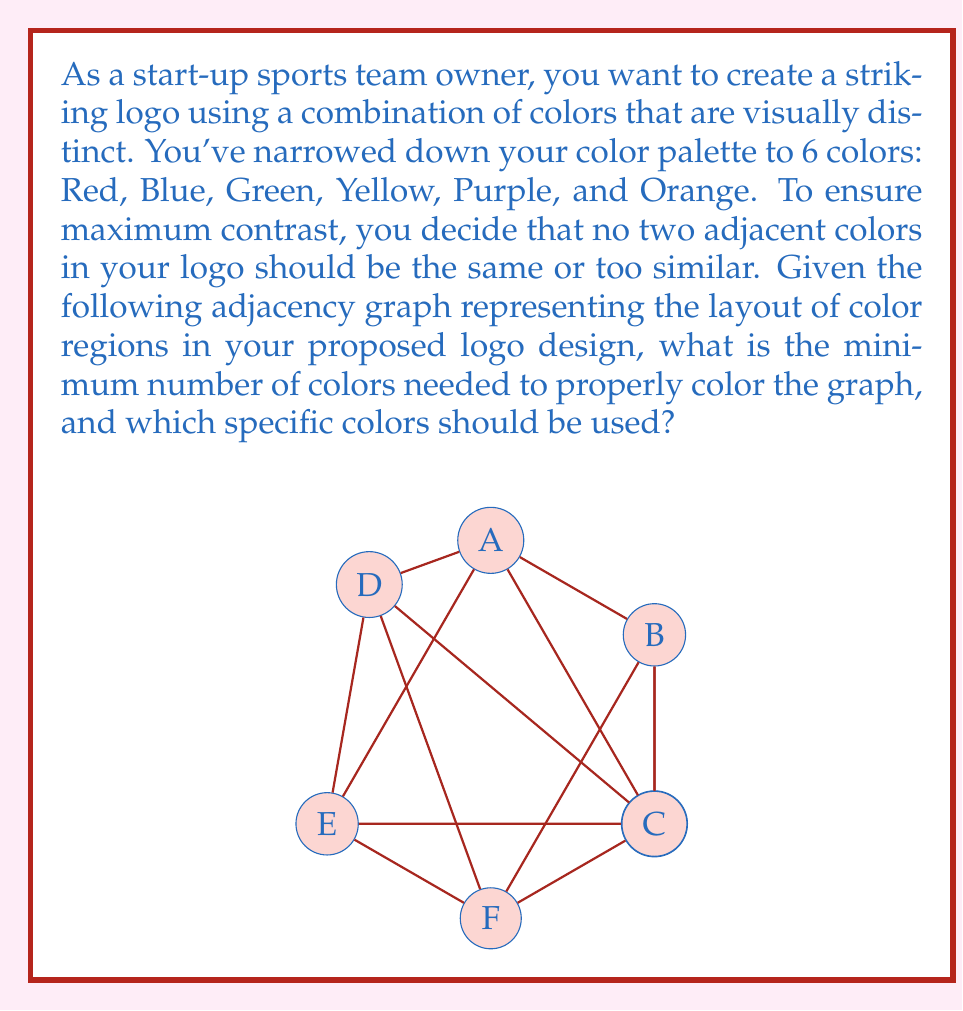Teach me how to tackle this problem. To solve this problem, we'll use the graph coloring algorithm and the concept of chromatic number.

Step 1: Analyze the graph
The given graph is a wheel graph with 7 vertices. It consists of a central vertex connected to all vertices of a 6-vertex cycle.

Step 2: Determine the chromatic number
For a wheel graph with an odd number of vertices (n), the chromatic number is always 4. This is because:
- The outer cycle requires at least 3 colors (as it's an odd cycle).
- The central vertex needs a 4th color, as it's connected to all other vertices.

Step 3: Color assignment
We can color the graph as follows:
- Use 3 colors (e.g., Red, Blue, Green) for the outer cycle, alternating them.
- Use the 4th color (e.g., Yellow) for the central vertex.

Specific color assignment:
A (center): Yellow
B, D, F: Red
C, E, G: Blue
B, D, F: Green

Step 4: Verify the coloring
- No two adjacent vertices have the same color.
- We've used exactly 4 colors.

Step 5: Optimality
This coloring is optimal because:
- We can't use fewer than 4 colors (as proven by the chromatic number).
- We don't need more than 4 colors to achieve a proper coloring.

Therefore, the minimum number of colors needed is 4, and we can use Red, Blue, Green, and Yellow from our palette to create a visually striking and properly colored logo.
Answer: 4 colors: Red, Blue, Green, Yellow 